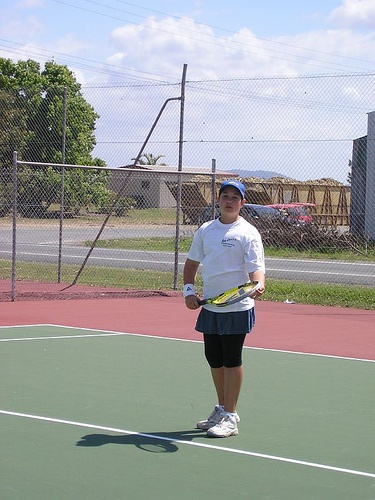Describe the objects in this image and their specific colors. I can see people in lavender, darkgray, black, white, and gray tones, tennis racket in lavender, gray, darkgray, olive, and black tones, car in lavender, gray, and black tones, and car in lavender, gray, brown, and lightpink tones in this image. 